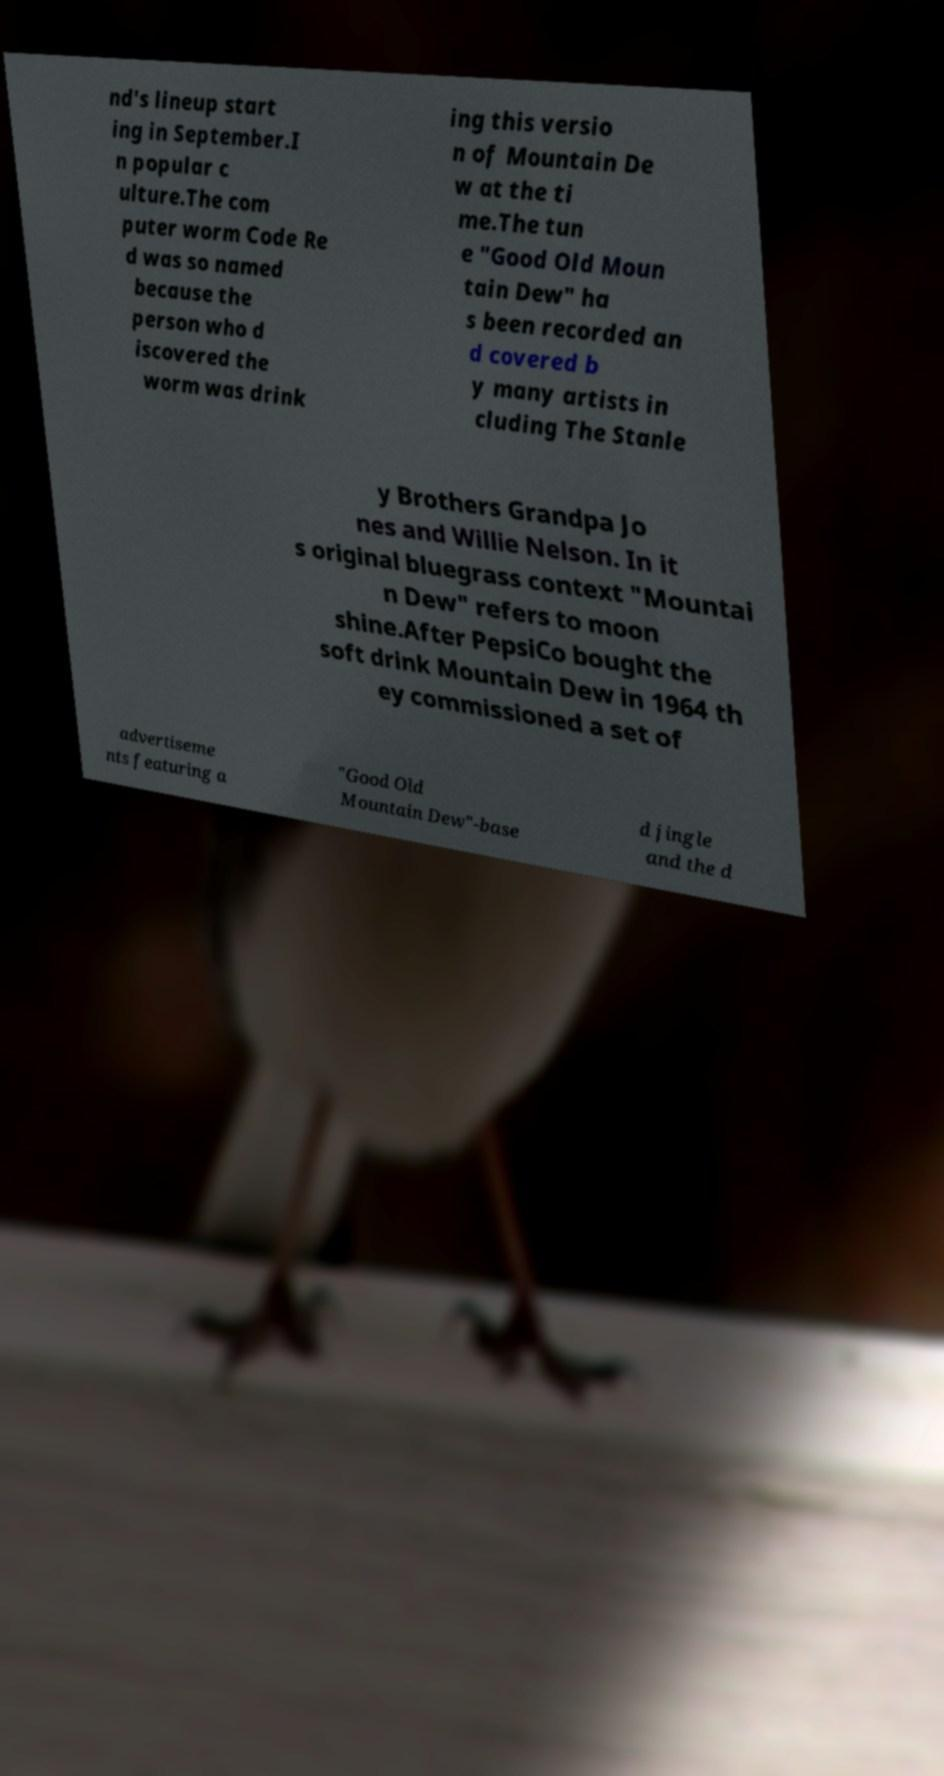For documentation purposes, I need the text within this image transcribed. Could you provide that? nd's lineup start ing in September.I n popular c ulture.The com puter worm Code Re d was so named because the person who d iscovered the worm was drink ing this versio n of Mountain De w at the ti me.The tun e "Good Old Moun tain Dew" ha s been recorded an d covered b y many artists in cluding The Stanle y Brothers Grandpa Jo nes and Willie Nelson. In it s original bluegrass context "Mountai n Dew" refers to moon shine.After PepsiCo bought the soft drink Mountain Dew in 1964 th ey commissioned a set of advertiseme nts featuring a "Good Old Mountain Dew"-base d jingle and the d 